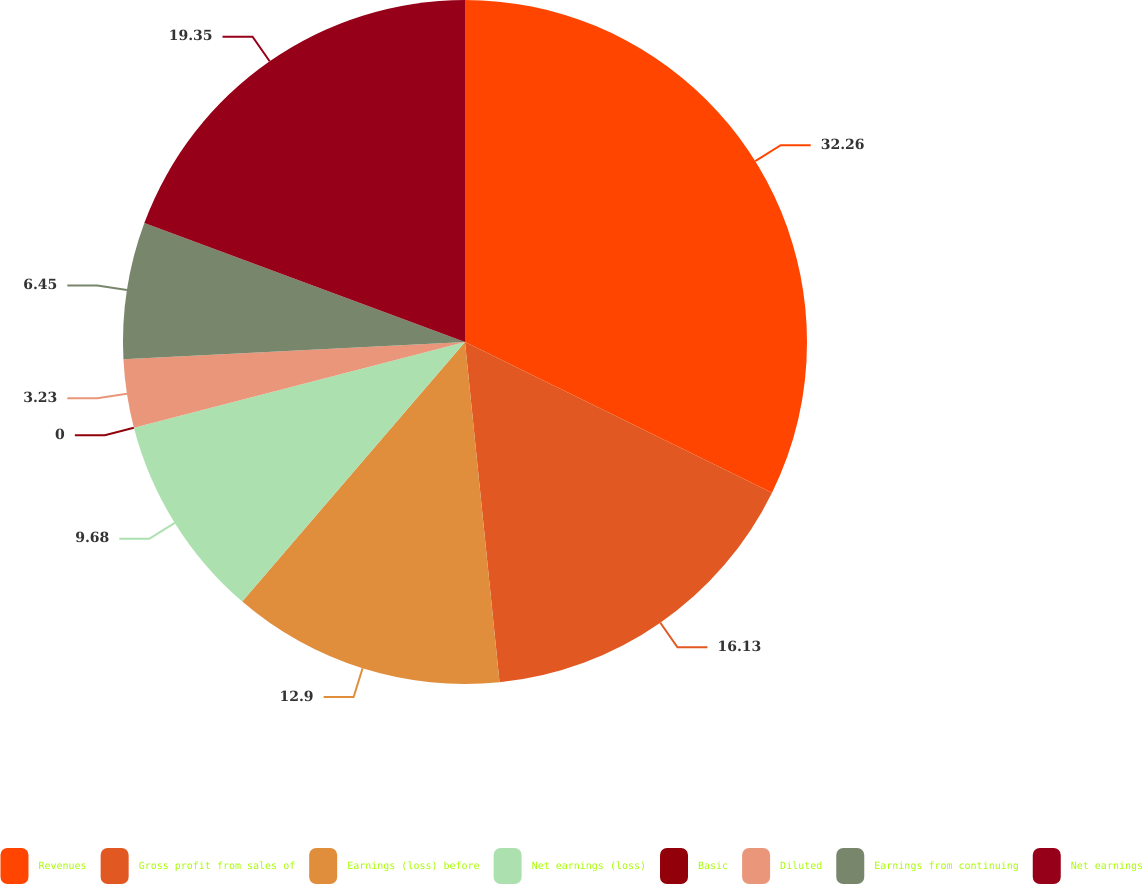<chart> <loc_0><loc_0><loc_500><loc_500><pie_chart><fcel>Revenues<fcel>Gross profit from sales of<fcel>Earnings (loss) before<fcel>Net earnings (loss)<fcel>Basic<fcel>Diluted<fcel>Earnings from continuing<fcel>Net earnings<nl><fcel>32.26%<fcel>16.13%<fcel>12.9%<fcel>9.68%<fcel>0.0%<fcel>3.23%<fcel>6.45%<fcel>19.35%<nl></chart> 